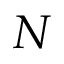<formula> <loc_0><loc_0><loc_500><loc_500>N</formula> 